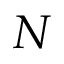<formula> <loc_0><loc_0><loc_500><loc_500>N</formula> 